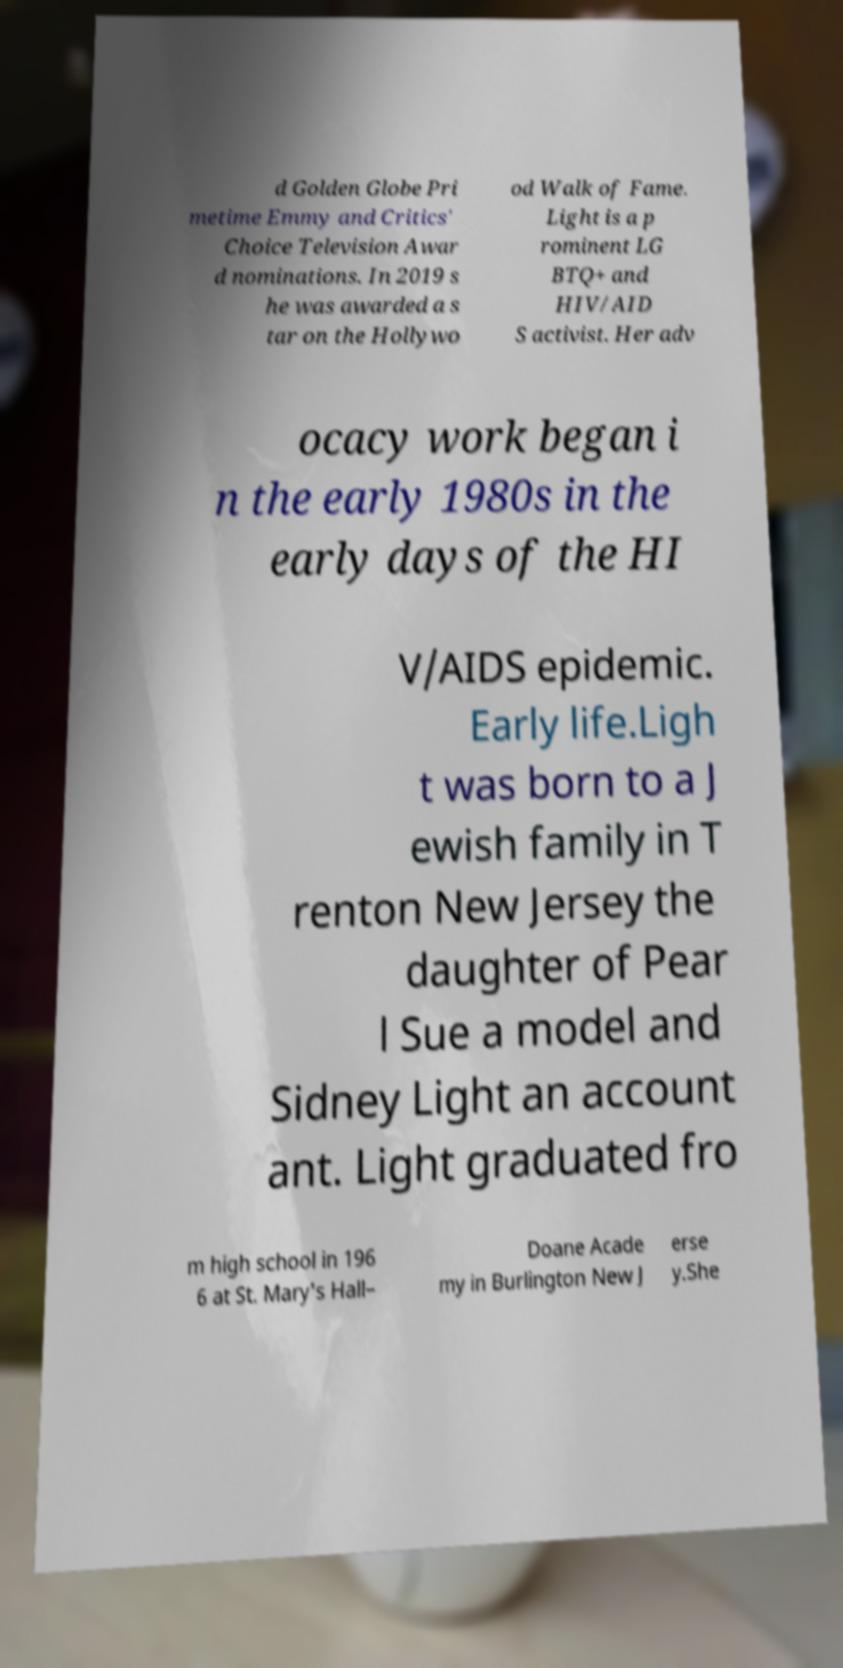Please identify and transcribe the text found in this image. d Golden Globe Pri metime Emmy and Critics' Choice Television Awar d nominations. In 2019 s he was awarded a s tar on the Hollywo od Walk of Fame. Light is a p rominent LG BTQ+ and HIV/AID S activist. Her adv ocacy work began i n the early 1980s in the early days of the HI V/AIDS epidemic. Early life.Ligh t was born to a J ewish family in T renton New Jersey the daughter of Pear l Sue a model and Sidney Light an account ant. Light graduated fro m high school in 196 6 at St. Mary's Hall– Doane Acade my in Burlington New J erse y.She 